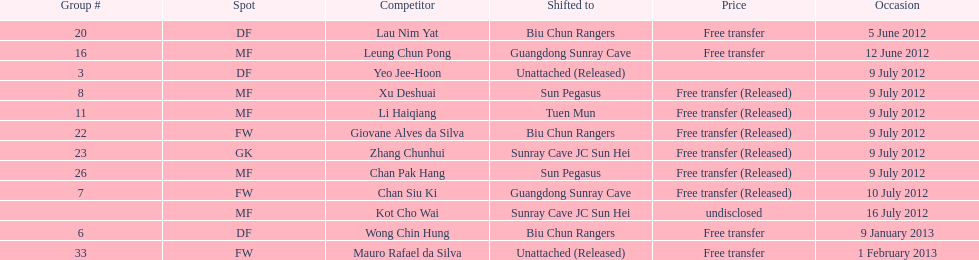Player transferred immediately before mauro rafael da silva Wong Chin Hung. 